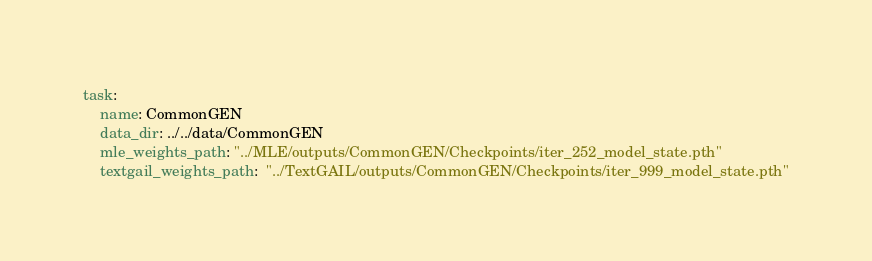Convert code to text. <code><loc_0><loc_0><loc_500><loc_500><_YAML_>task:
    name: CommonGEN
    data_dir: ../../data/CommonGEN
    mle_weights_path: "../MLE/outputs/CommonGEN/Checkpoints/iter_252_model_state.pth"
    textgail_weights_path:  "../TextGAIL/outputs/CommonGEN/Checkpoints/iter_999_model_state.pth"</code> 